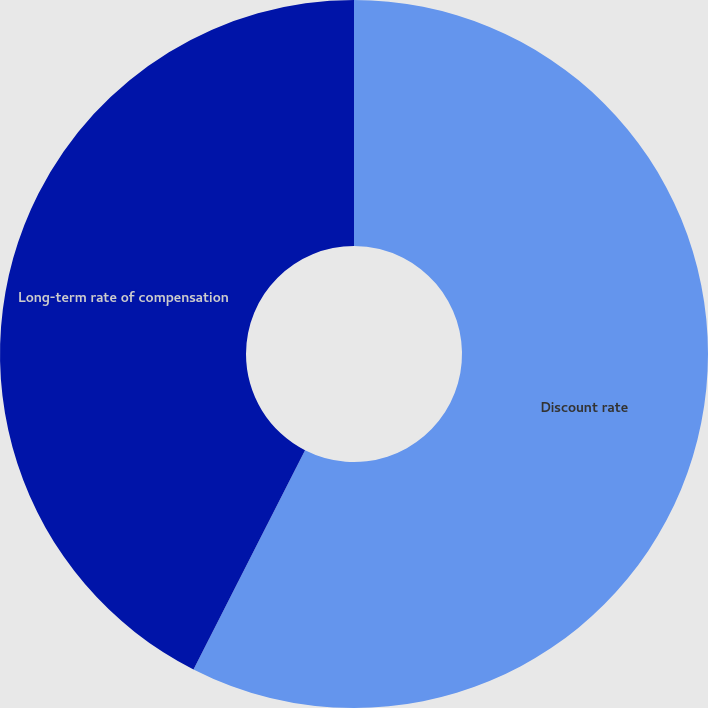Convert chart. <chart><loc_0><loc_0><loc_500><loc_500><pie_chart><fcel>Discount rate<fcel>Long-term rate of compensation<nl><fcel>57.49%<fcel>42.51%<nl></chart> 